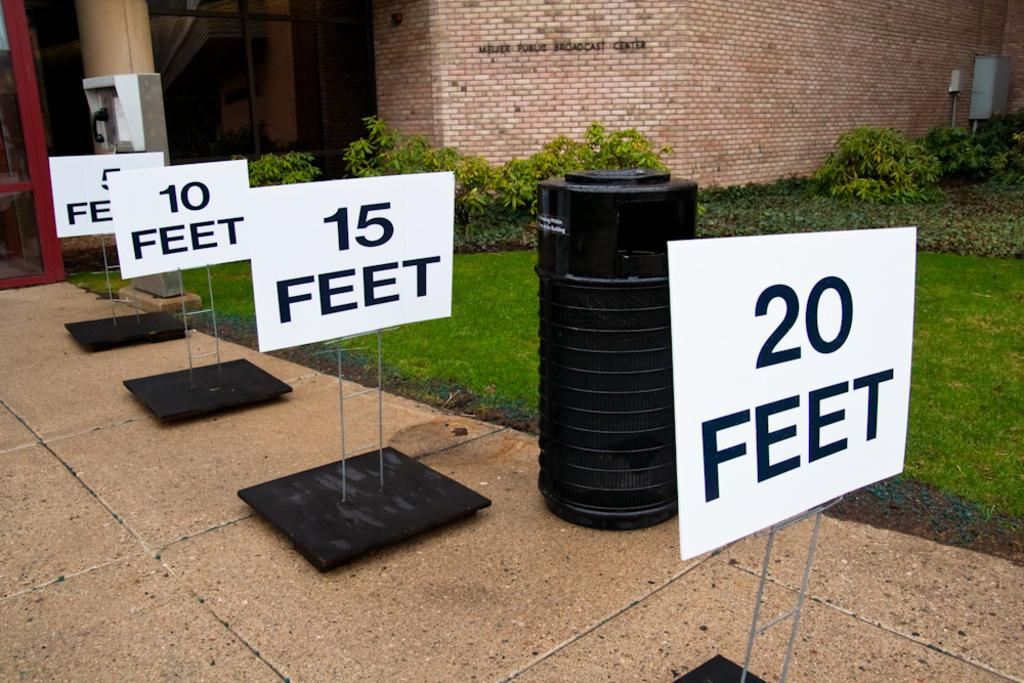Provide a one-sentence caption for the provided image. four different white signs that read five ten fifteen and twenty feet on them. 